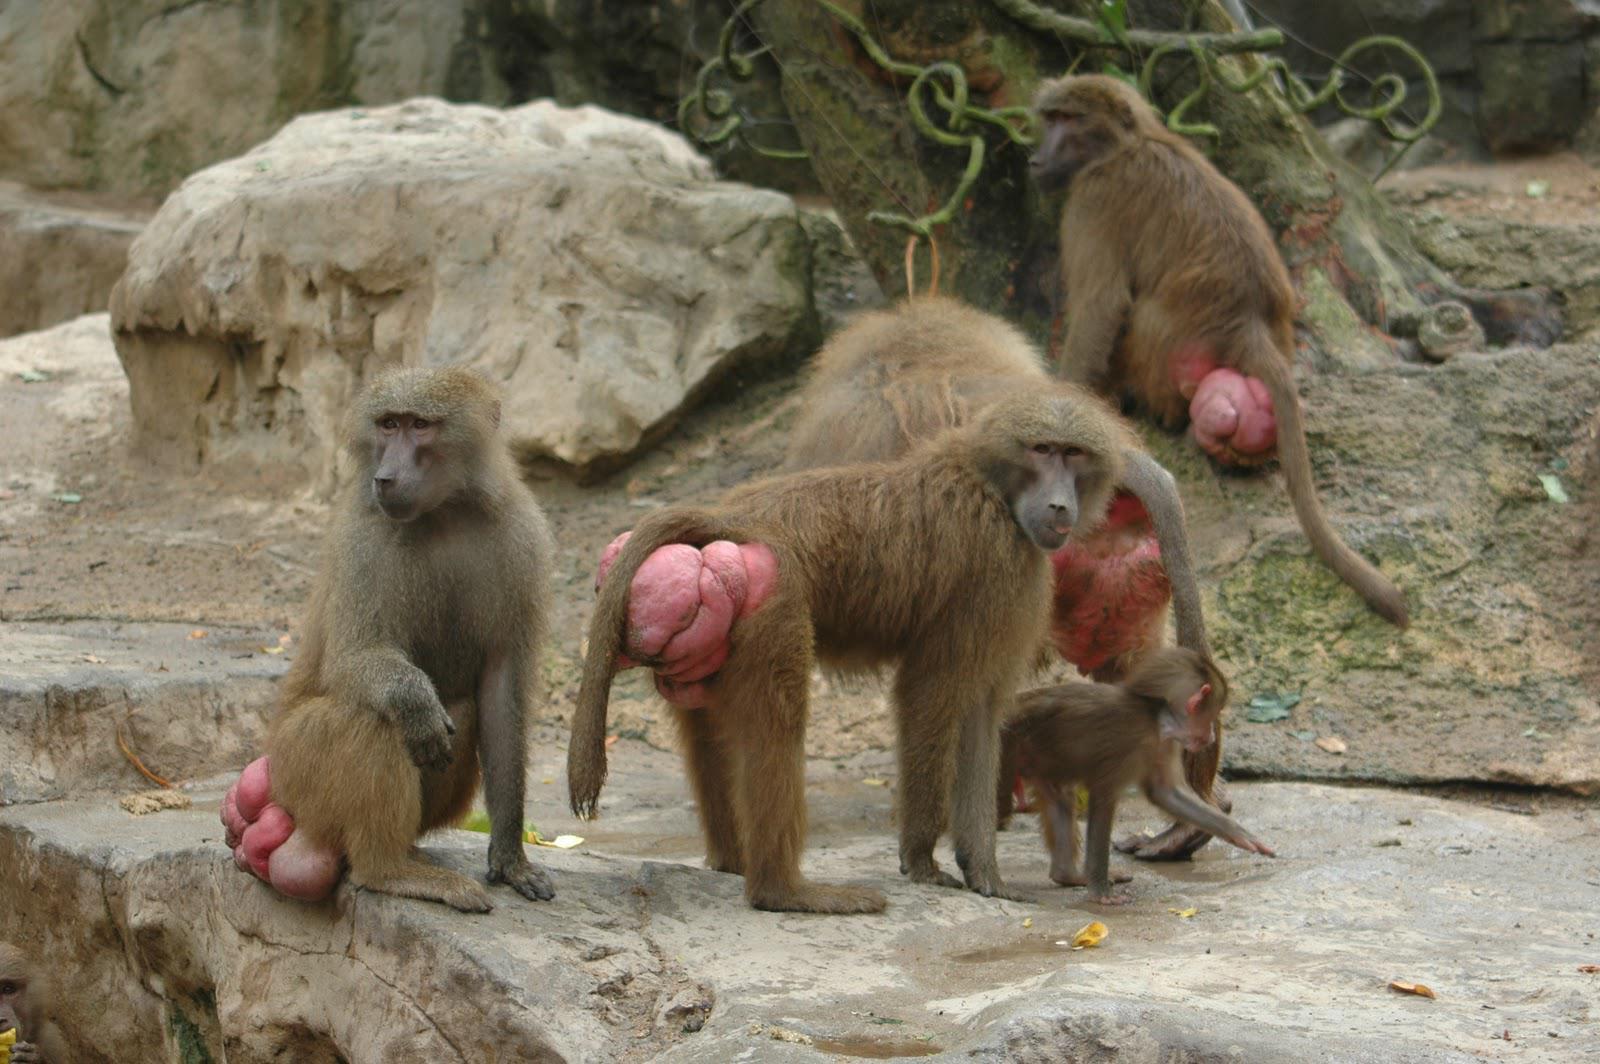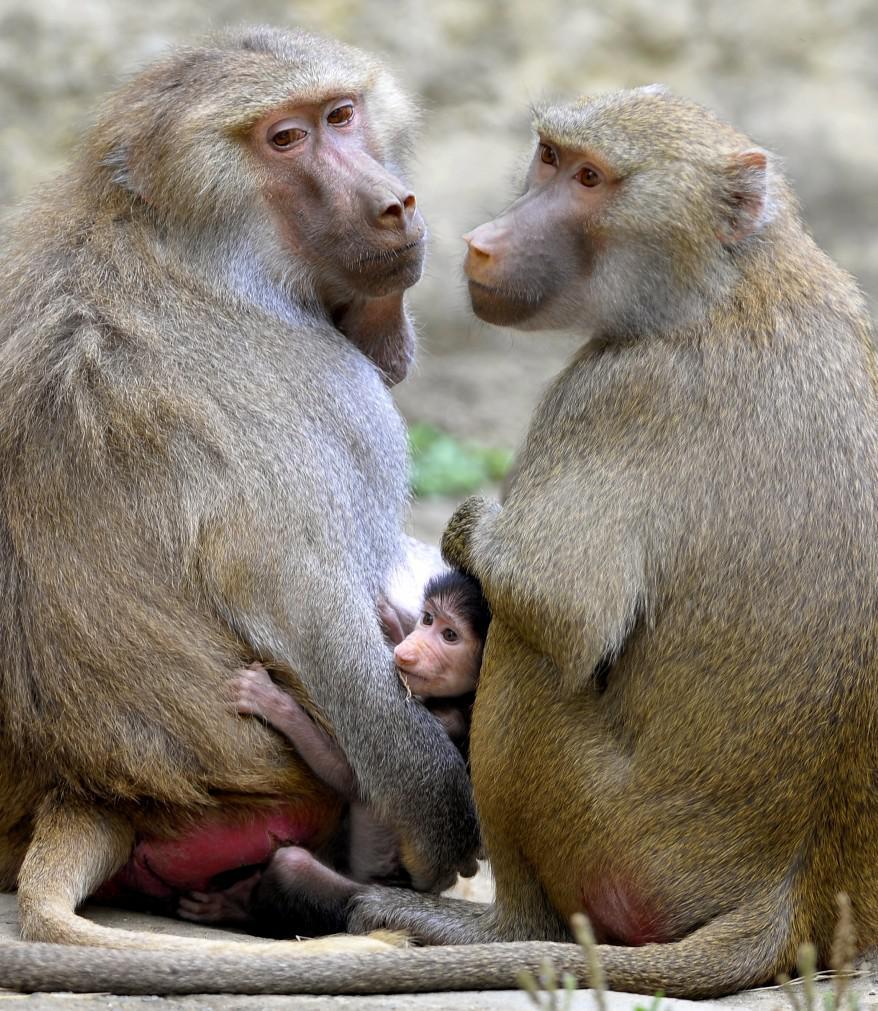The first image is the image on the left, the second image is the image on the right. For the images displayed, is the sentence "In the image on the left, there are only 2 monkeys and they have their heads turned in the same direction." factually correct? Answer yes or no. No. The first image is the image on the left, the second image is the image on the right. Examine the images to the left and right. Is the description "Each image shows exactly two baboons interacting, and the left image shows one baboon grooming the fur of a baboon with its head lowered and paws down." accurate? Answer yes or no. No. 